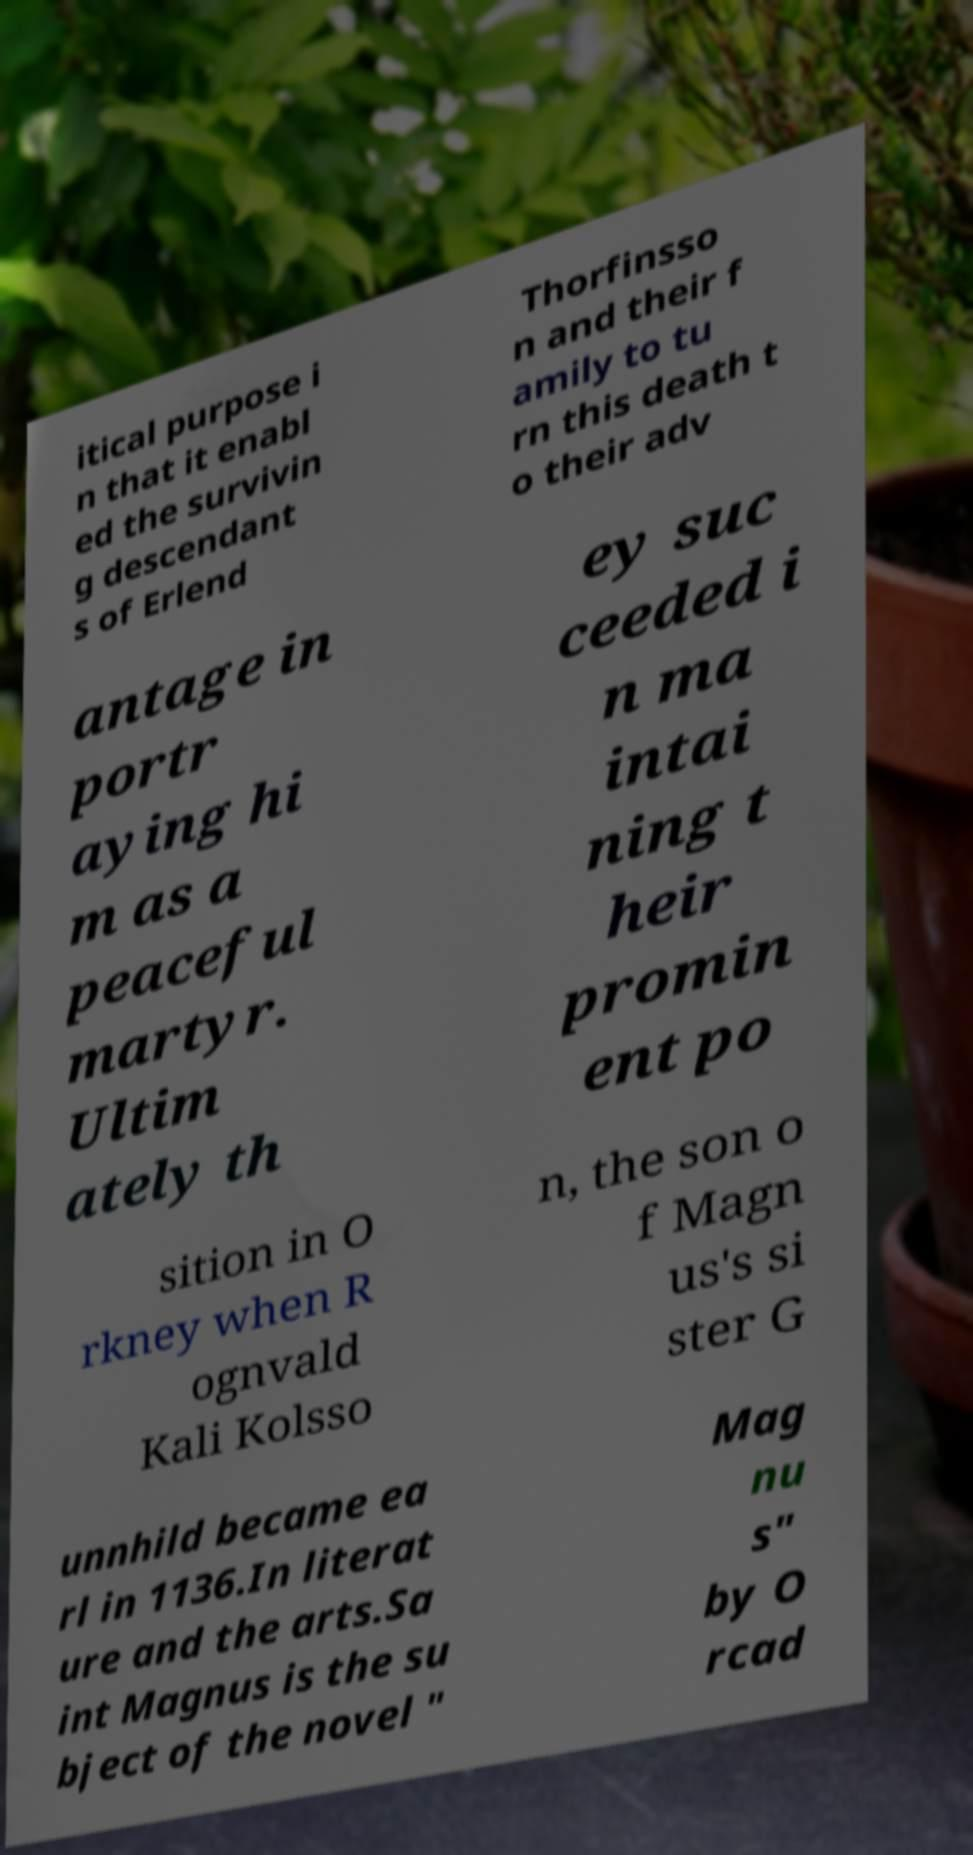Please read and relay the text visible in this image. What does it say? itical purpose i n that it enabl ed the survivin g descendant s of Erlend Thorfinsso n and their f amily to tu rn this death t o their adv antage in portr aying hi m as a peaceful martyr. Ultim ately th ey suc ceeded i n ma intai ning t heir promin ent po sition in O rkney when R ognvald Kali Kolsso n, the son o f Magn us's si ster G unnhild became ea rl in 1136.In literat ure and the arts.Sa int Magnus is the su bject of the novel " Mag nu s" by O rcad 